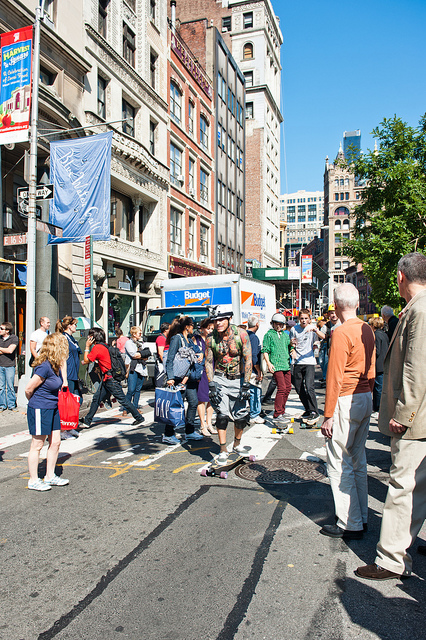Read and extract the text from this image. Budget E-16 5 